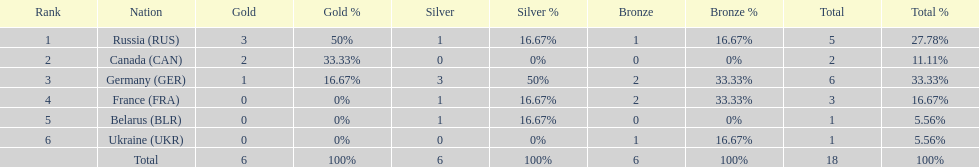What country only received gold medals in the 1994 winter olympics biathlon? Canada (CAN). 